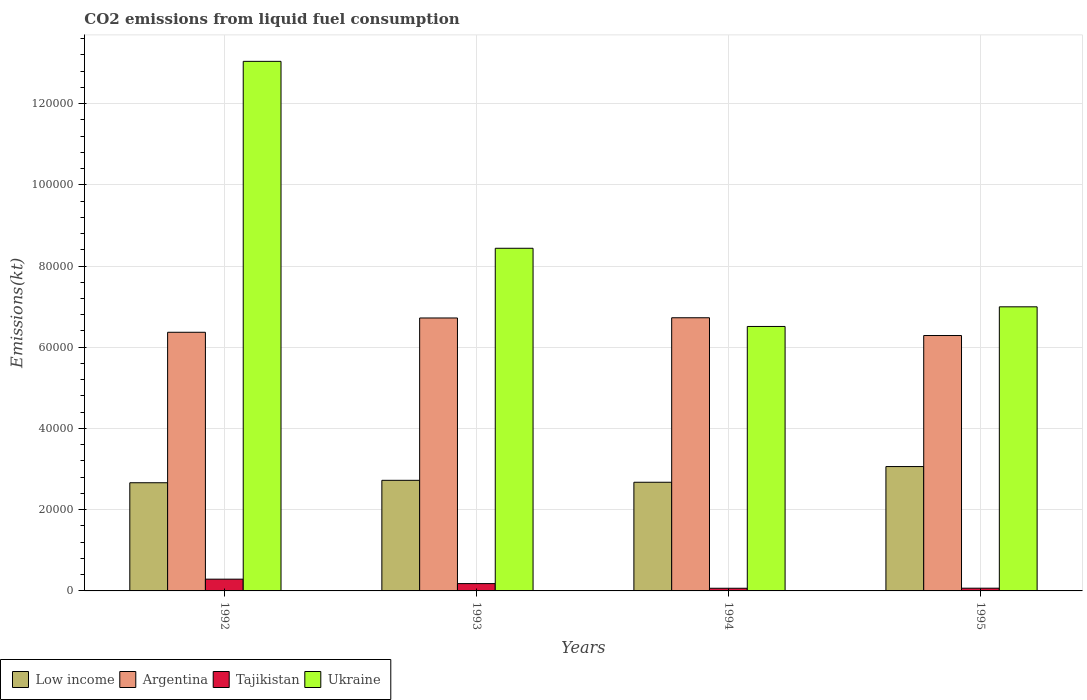How many groups of bars are there?
Provide a short and direct response. 4. Are the number of bars on each tick of the X-axis equal?
Give a very brief answer. Yes. How many bars are there on the 4th tick from the left?
Provide a short and direct response. 4. What is the label of the 4th group of bars from the left?
Keep it short and to the point. 1995. What is the amount of CO2 emitted in Argentina in 1995?
Your response must be concise. 6.29e+04. Across all years, what is the maximum amount of CO2 emitted in Low income?
Give a very brief answer. 3.06e+04. Across all years, what is the minimum amount of CO2 emitted in Tajikistan?
Your answer should be very brief. 656.39. In which year was the amount of CO2 emitted in Low income minimum?
Your answer should be very brief. 1992. What is the total amount of CO2 emitted in Argentina in the graph?
Your answer should be compact. 2.61e+05. What is the difference between the amount of CO2 emitted in Ukraine in 1992 and that in 1993?
Your response must be concise. 4.60e+04. What is the difference between the amount of CO2 emitted in Low income in 1992 and the amount of CO2 emitted in Ukraine in 1995?
Your response must be concise. -4.33e+04. What is the average amount of CO2 emitted in Argentina per year?
Provide a short and direct response. 6.53e+04. In the year 1994, what is the difference between the amount of CO2 emitted in Argentina and amount of CO2 emitted in Tajikistan?
Make the answer very short. 6.66e+04. In how many years, is the amount of CO2 emitted in Low income greater than 92000 kt?
Your response must be concise. 0. What is the ratio of the amount of CO2 emitted in Tajikistan in 1992 to that in 1993?
Offer a terse response. 1.61. Is the difference between the amount of CO2 emitted in Argentina in 1993 and 1995 greater than the difference between the amount of CO2 emitted in Tajikistan in 1993 and 1995?
Ensure brevity in your answer.  Yes. What is the difference between the highest and the second highest amount of CO2 emitted in Tajikistan?
Your response must be concise. 1092.77. What is the difference between the highest and the lowest amount of CO2 emitted in Low income?
Your answer should be very brief. 3987. In how many years, is the amount of CO2 emitted in Low income greater than the average amount of CO2 emitted in Low income taken over all years?
Your answer should be very brief. 1. Is the sum of the amount of CO2 emitted in Low income in 1993 and 1994 greater than the maximum amount of CO2 emitted in Tajikistan across all years?
Offer a terse response. Yes. What does the 3rd bar from the left in 1992 represents?
Your answer should be very brief. Tajikistan. What does the 2nd bar from the right in 1993 represents?
Ensure brevity in your answer.  Tajikistan. How many years are there in the graph?
Your answer should be very brief. 4. What is the difference between two consecutive major ticks on the Y-axis?
Your answer should be very brief. 2.00e+04. Where does the legend appear in the graph?
Your answer should be very brief. Bottom left. How many legend labels are there?
Give a very brief answer. 4. What is the title of the graph?
Ensure brevity in your answer.  CO2 emissions from liquid fuel consumption. What is the label or title of the X-axis?
Provide a short and direct response. Years. What is the label or title of the Y-axis?
Provide a short and direct response. Emissions(kt). What is the Emissions(kt) of Low income in 1992?
Give a very brief answer. 2.66e+04. What is the Emissions(kt) of Argentina in 1992?
Your response must be concise. 6.37e+04. What is the Emissions(kt) in Tajikistan in 1992?
Make the answer very short. 2893.26. What is the Emissions(kt) of Ukraine in 1992?
Offer a terse response. 1.30e+05. What is the Emissions(kt) in Low income in 1993?
Your answer should be compact. 2.72e+04. What is the Emissions(kt) of Argentina in 1993?
Offer a terse response. 6.72e+04. What is the Emissions(kt) in Tajikistan in 1993?
Provide a short and direct response. 1800.5. What is the Emissions(kt) of Ukraine in 1993?
Provide a succinct answer. 8.44e+04. What is the Emissions(kt) of Low income in 1994?
Give a very brief answer. 2.68e+04. What is the Emissions(kt) of Argentina in 1994?
Your response must be concise. 6.73e+04. What is the Emissions(kt) in Tajikistan in 1994?
Your response must be concise. 656.39. What is the Emissions(kt) in Ukraine in 1994?
Your answer should be compact. 6.51e+04. What is the Emissions(kt) in Low income in 1995?
Make the answer very short. 3.06e+04. What is the Emissions(kt) in Argentina in 1995?
Your response must be concise. 6.29e+04. What is the Emissions(kt) of Tajikistan in 1995?
Provide a short and direct response. 671.06. What is the Emissions(kt) of Ukraine in 1995?
Provide a short and direct response. 7.00e+04. Across all years, what is the maximum Emissions(kt) of Low income?
Your answer should be compact. 3.06e+04. Across all years, what is the maximum Emissions(kt) in Argentina?
Your response must be concise. 6.73e+04. Across all years, what is the maximum Emissions(kt) in Tajikistan?
Make the answer very short. 2893.26. Across all years, what is the maximum Emissions(kt) in Ukraine?
Provide a short and direct response. 1.30e+05. Across all years, what is the minimum Emissions(kt) of Low income?
Your answer should be very brief. 2.66e+04. Across all years, what is the minimum Emissions(kt) in Argentina?
Make the answer very short. 6.29e+04. Across all years, what is the minimum Emissions(kt) in Tajikistan?
Keep it short and to the point. 656.39. Across all years, what is the minimum Emissions(kt) of Ukraine?
Keep it short and to the point. 6.51e+04. What is the total Emissions(kt) of Low income in the graph?
Your response must be concise. 1.11e+05. What is the total Emissions(kt) in Argentina in the graph?
Give a very brief answer. 2.61e+05. What is the total Emissions(kt) in Tajikistan in the graph?
Offer a terse response. 6021.21. What is the total Emissions(kt) in Ukraine in the graph?
Your answer should be very brief. 3.50e+05. What is the difference between the Emissions(kt) of Low income in 1992 and that in 1993?
Provide a short and direct response. -598.02. What is the difference between the Emissions(kt) of Argentina in 1992 and that in 1993?
Offer a very short reply. -3520.32. What is the difference between the Emissions(kt) in Tajikistan in 1992 and that in 1993?
Keep it short and to the point. 1092.77. What is the difference between the Emissions(kt) in Ukraine in 1992 and that in 1993?
Give a very brief answer. 4.60e+04. What is the difference between the Emissions(kt) of Low income in 1992 and that in 1994?
Offer a very short reply. -118.76. What is the difference between the Emissions(kt) of Argentina in 1992 and that in 1994?
Provide a succinct answer. -3575.32. What is the difference between the Emissions(kt) in Tajikistan in 1992 and that in 1994?
Your answer should be compact. 2236.87. What is the difference between the Emissions(kt) in Ukraine in 1992 and that in 1994?
Your response must be concise. 6.53e+04. What is the difference between the Emissions(kt) in Low income in 1992 and that in 1995?
Your response must be concise. -3987. What is the difference between the Emissions(kt) of Argentina in 1992 and that in 1995?
Your answer should be compact. 799.41. What is the difference between the Emissions(kt) in Tajikistan in 1992 and that in 1995?
Make the answer very short. 2222.2. What is the difference between the Emissions(kt) in Ukraine in 1992 and that in 1995?
Provide a succinct answer. 6.04e+04. What is the difference between the Emissions(kt) of Low income in 1993 and that in 1994?
Your response must be concise. 479.26. What is the difference between the Emissions(kt) in Argentina in 1993 and that in 1994?
Your response must be concise. -55.01. What is the difference between the Emissions(kt) in Tajikistan in 1993 and that in 1994?
Provide a short and direct response. 1144.1. What is the difference between the Emissions(kt) of Ukraine in 1993 and that in 1994?
Keep it short and to the point. 1.93e+04. What is the difference between the Emissions(kt) of Low income in 1993 and that in 1995?
Provide a short and direct response. -3388.98. What is the difference between the Emissions(kt) in Argentina in 1993 and that in 1995?
Your answer should be very brief. 4319.73. What is the difference between the Emissions(kt) of Tajikistan in 1993 and that in 1995?
Provide a succinct answer. 1129.44. What is the difference between the Emissions(kt) in Ukraine in 1993 and that in 1995?
Give a very brief answer. 1.44e+04. What is the difference between the Emissions(kt) in Low income in 1994 and that in 1995?
Ensure brevity in your answer.  -3868.24. What is the difference between the Emissions(kt) in Argentina in 1994 and that in 1995?
Offer a very short reply. 4374.73. What is the difference between the Emissions(kt) in Tajikistan in 1994 and that in 1995?
Your answer should be compact. -14.67. What is the difference between the Emissions(kt) of Ukraine in 1994 and that in 1995?
Your response must be concise. -4836.77. What is the difference between the Emissions(kt) in Low income in 1992 and the Emissions(kt) in Argentina in 1993?
Ensure brevity in your answer.  -4.06e+04. What is the difference between the Emissions(kt) of Low income in 1992 and the Emissions(kt) of Tajikistan in 1993?
Make the answer very short. 2.48e+04. What is the difference between the Emissions(kt) of Low income in 1992 and the Emissions(kt) of Ukraine in 1993?
Offer a terse response. -5.77e+04. What is the difference between the Emissions(kt) of Argentina in 1992 and the Emissions(kt) of Tajikistan in 1993?
Make the answer very short. 6.19e+04. What is the difference between the Emissions(kt) in Argentina in 1992 and the Emissions(kt) in Ukraine in 1993?
Your answer should be very brief. -2.07e+04. What is the difference between the Emissions(kt) of Tajikistan in 1992 and the Emissions(kt) of Ukraine in 1993?
Offer a very short reply. -8.15e+04. What is the difference between the Emissions(kt) in Low income in 1992 and the Emissions(kt) in Argentina in 1994?
Provide a short and direct response. -4.06e+04. What is the difference between the Emissions(kt) of Low income in 1992 and the Emissions(kt) of Tajikistan in 1994?
Offer a terse response. 2.60e+04. What is the difference between the Emissions(kt) in Low income in 1992 and the Emissions(kt) in Ukraine in 1994?
Offer a terse response. -3.85e+04. What is the difference between the Emissions(kt) of Argentina in 1992 and the Emissions(kt) of Tajikistan in 1994?
Offer a very short reply. 6.30e+04. What is the difference between the Emissions(kt) of Argentina in 1992 and the Emissions(kt) of Ukraine in 1994?
Your answer should be very brief. -1430.13. What is the difference between the Emissions(kt) in Tajikistan in 1992 and the Emissions(kt) in Ukraine in 1994?
Offer a very short reply. -6.22e+04. What is the difference between the Emissions(kt) of Low income in 1992 and the Emissions(kt) of Argentina in 1995?
Provide a succinct answer. -3.63e+04. What is the difference between the Emissions(kt) of Low income in 1992 and the Emissions(kt) of Tajikistan in 1995?
Provide a short and direct response. 2.60e+04. What is the difference between the Emissions(kt) of Low income in 1992 and the Emissions(kt) of Ukraine in 1995?
Offer a very short reply. -4.33e+04. What is the difference between the Emissions(kt) of Argentina in 1992 and the Emissions(kt) of Tajikistan in 1995?
Ensure brevity in your answer.  6.30e+04. What is the difference between the Emissions(kt) in Argentina in 1992 and the Emissions(kt) in Ukraine in 1995?
Offer a terse response. -6266.9. What is the difference between the Emissions(kt) of Tajikistan in 1992 and the Emissions(kt) of Ukraine in 1995?
Offer a terse response. -6.71e+04. What is the difference between the Emissions(kt) of Low income in 1993 and the Emissions(kt) of Argentina in 1994?
Your answer should be compact. -4.00e+04. What is the difference between the Emissions(kt) in Low income in 1993 and the Emissions(kt) in Tajikistan in 1994?
Offer a terse response. 2.66e+04. What is the difference between the Emissions(kt) in Low income in 1993 and the Emissions(kt) in Ukraine in 1994?
Offer a terse response. -3.79e+04. What is the difference between the Emissions(kt) in Argentina in 1993 and the Emissions(kt) in Tajikistan in 1994?
Keep it short and to the point. 6.65e+04. What is the difference between the Emissions(kt) of Argentina in 1993 and the Emissions(kt) of Ukraine in 1994?
Provide a succinct answer. 2090.19. What is the difference between the Emissions(kt) in Tajikistan in 1993 and the Emissions(kt) in Ukraine in 1994?
Keep it short and to the point. -6.33e+04. What is the difference between the Emissions(kt) in Low income in 1993 and the Emissions(kt) in Argentina in 1995?
Your answer should be compact. -3.57e+04. What is the difference between the Emissions(kt) in Low income in 1993 and the Emissions(kt) in Tajikistan in 1995?
Offer a terse response. 2.66e+04. What is the difference between the Emissions(kt) of Low income in 1993 and the Emissions(kt) of Ukraine in 1995?
Your response must be concise. -4.27e+04. What is the difference between the Emissions(kt) in Argentina in 1993 and the Emissions(kt) in Tajikistan in 1995?
Your response must be concise. 6.65e+04. What is the difference between the Emissions(kt) of Argentina in 1993 and the Emissions(kt) of Ukraine in 1995?
Give a very brief answer. -2746.58. What is the difference between the Emissions(kt) of Tajikistan in 1993 and the Emissions(kt) of Ukraine in 1995?
Provide a succinct answer. -6.82e+04. What is the difference between the Emissions(kt) of Low income in 1994 and the Emissions(kt) of Argentina in 1995?
Your response must be concise. -3.61e+04. What is the difference between the Emissions(kt) of Low income in 1994 and the Emissions(kt) of Tajikistan in 1995?
Make the answer very short. 2.61e+04. What is the difference between the Emissions(kt) in Low income in 1994 and the Emissions(kt) in Ukraine in 1995?
Your answer should be compact. -4.32e+04. What is the difference between the Emissions(kt) in Argentina in 1994 and the Emissions(kt) in Tajikistan in 1995?
Your answer should be compact. 6.66e+04. What is the difference between the Emissions(kt) of Argentina in 1994 and the Emissions(kt) of Ukraine in 1995?
Keep it short and to the point. -2691.58. What is the difference between the Emissions(kt) of Tajikistan in 1994 and the Emissions(kt) of Ukraine in 1995?
Your answer should be compact. -6.93e+04. What is the average Emissions(kt) of Low income per year?
Provide a short and direct response. 2.78e+04. What is the average Emissions(kt) of Argentina per year?
Your answer should be compact. 6.53e+04. What is the average Emissions(kt) in Tajikistan per year?
Provide a short and direct response. 1505.3. What is the average Emissions(kt) of Ukraine per year?
Your response must be concise. 8.75e+04. In the year 1992, what is the difference between the Emissions(kt) in Low income and Emissions(kt) in Argentina?
Your response must be concise. -3.70e+04. In the year 1992, what is the difference between the Emissions(kt) in Low income and Emissions(kt) in Tajikistan?
Offer a terse response. 2.37e+04. In the year 1992, what is the difference between the Emissions(kt) in Low income and Emissions(kt) in Ukraine?
Make the answer very short. -1.04e+05. In the year 1992, what is the difference between the Emissions(kt) of Argentina and Emissions(kt) of Tajikistan?
Your answer should be very brief. 6.08e+04. In the year 1992, what is the difference between the Emissions(kt) of Argentina and Emissions(kt) of Ukraine?
Your response must be concise. -6.67e+04. In the year 1992, what is the difference between the Emissions(kt) in Tajikistan and Emissions(kt) in Ukraine?
Your response must be concise. -1.27e+05. In the year 1993, what is the difference between the Emissions(kt) of Low income and Emissions(kt) of Argentina?
Offer a terse response. -4.00e+04. In the year 1993, what is the difference between the Emissions(kt) of Low income and Emissions(kt) of Tajikistan?
Ensure brevity in your answer.  2.54e+04. In the year 1993, what is the difference between the Emissions(kt) of Low income and Emissions(kt) of Ukraine?
Make the answer very short. -5.71e+04. In the year 1993, what is the difference between the Emissions(kt) in Argentina and Emissions(kt) in Tajikistan?
Your answer should be very brief. 6.54e+04. In the year 1993, what is the difference between the Emissions(kt) of Argentina and Emissions(kt) of Ukraine?
Give a very brief answer. -1.72e+04. In the year 1993, what is the difference between the Emissions(kt) in Tajikistan and Emissions(kt) in Ukraine?
Offer a terse response. -8.26e+04. In the year 1994, what is the difference between the Emissions(kt) in Low income and Emissions(kt) in Argentina?
Your answer should be very brief. -4.05e+04. In the year 1994, what is the difference between the Emissions(kt) in Low income and Emissions(kt) in Tajikistan?
Give a very brief answer. 2.61e+04. In the year 1994, what is the difference between the Emissions(kt) of Low income and Emissions(kt) of Ukraine?
Offer a very short reply. -3.84e+04. In the year 1994, what is the difference between the Emissions(kt) of Argentina and Emissions(kt) of Tajikistan?
Provide a short and direct response. 6.66e+04. In the year 1994, what is the difference between the Emissions(kt) of Argentina and Emissions(kt) of Ukraine?
Provide a short and direct response. 2145.2. In the year 1994, what is the difference between the Emissions(kt) of Tajikistan and Emissions(kt) of Ukraine?
Your response must be concise. -6.45e+04. In the year 1995, what is the difference between the Emissions(kt) of Low income and Emissions(kt) of Argentina?
Keep it short and to the point. -3.23e+04. In the year 1995, what is the difference between the Emissions(kt) in Low income and Emissions(kt) in Tajikistan?
Provide a succinct answer. 3.00e+04. In the year 1995, what is the difference between the Emissions(kt) in Low income and Emissions(kt) in Ukraine?
Provide a short and direct response. -3.93e+04. In the year 1995, what is the difference between the Emissions(kt) in Argentina and Emissions(kt) in Tajikistan?
Ensure brevity in your answer.  6.22e+04. In the year 1995, what is the difference between the Emissions(kt) of Argentina and Emissions(kt) of Ukraine?
Ensure brevity in your answer.  -7066.31. In the year 1995, what is the difference between the Emissions(kt) of Tajikistan and Emissions(kt) of Ukraine?
Give a very brief answer. -6.93e+04. What is the ratio of the Emissions(kt) in Low income in 1992 to that in 1993?
Make the answer very short. 0.98. What is the ratio of the Emissions(kt) in Argentina in 1992 to that in 1993?
Your response must be concise. 0.95. What is the ratio of the Emissions(kt) in Tajikistan in 1992 to that in 1993?
Give a very brief answer. 1.61. What is the ratio of the Emissions(kt) of Ukraine in 1992 to that in 1993?
Offer a very short reply. 1.55. What is the ratio of the Emissions(kt) of Low income in 1992 to that in 1994?
Your answer should be very brief. 1. What is the ratio of the Emissions(kt) of Argentina in 1992 to that in 1994?
Offer a terse response. 0.95. What is the ratio of the Emissions(kt) in Tajikistan in 1992 to that in 1994?
Ensure brevity in your answer.  4.41. What is the ratio of the Emissions(kt) in Ukraine in 1992 to that in 1994?
Ensure brevity in your answer.  2. What is the ratio of the Emissions(kt) in Low income in 1992 to that in 1995?
Ensure brevity in your answer.  0.87. What is the ratio of the Emissions(kt) of Argentina in 1992 to that in 1995?
Ensure brevity in your answer.  1.01. What is the ratio of the Emissions(kt) in Tajikistan in 1992 to that in 1995?
Provide a short and direct response. 4.31. What is the ratio of the Emissions(kt) in Ukraine in 1992 to that in 1995?
Offer a terse response. 1.86. What is the ratio of the Emissions(kt) in Low income in 1993 to that in 1994?
Your answer should be very brief. 1.02. What is the ratio of the Emissions(kt) in Tajikistan in 1993 to that in 1994?
Provide a succinct answer. 2.74. What is the ratio of the Emissions(kt) of Ukraine in 1993 to that in 1994?
Your answer should be very brief. 1.3. What is the ratio of the Emissions(kt) in Low income in 1993 to that in 1995?
Give a very brief answer. 0.89. What is the ratio of the Emissions(kt) of Argentina in 1993 to that in 1995?
Your response must be concise. 1.07. What is the ratio of the Emissions(kt) of Tajikistan in 1993 to that in 1995?
Offer a very short reply. 2.68. What is the ratio of the Emissions(kt) of Ukraine in 1993 to that in 1995?
Provide a short and direct response. 1.21. What is the ratio of the Emissions(kt) of Low income in 1994 to that in 1995?
Give a very brief answer. 0.87. What is the ratio of the Emissions(kt) of Argentina in 1994 to that in 1995?
Your response must be concise. 1.07. What is the ratio of the Emissions(kt) of Tajikistan in 1994 to that in 1995?
Provide a succinct answer. 0.98. What is the ratio of the Emissions(kt) of Ukraine in 1994 to that in 1995?
Provide a succinct answer. 0.93. What is the difference between the highest and the second highest Emissions(kt) of Low income?
Make the answer very short. 3388.98. What is the difference between the highest and the second highest Emissions(kt) in Argentina?
Your answer should be very brief. 55.01. What is the difference between the highest and the second highest Emissions(kt) of Tajikistan?
Ensure brevity in your answer.  1092.77. What is the difference between the highest and the second highest Emissions(kt) of Ukraine?
Provide a short and direct response. 4.60e+04. What is the difference between the highest and the lowest Emissions(kt) in Low income?
Make the answer very short. 3987. What is the difference between the highest and the lowest Emissions(kt) in Argentina?
Give a very brief answer. 4374.73. What is the difference between the highest and the lowest Emissions(kt) in Tajikistan?
Keep it short and to the point. 2236.87. What is the difference between the highest and the lowest Emissions(kt) of Ukraine?
Your response must be concise. 6.53e+04. 